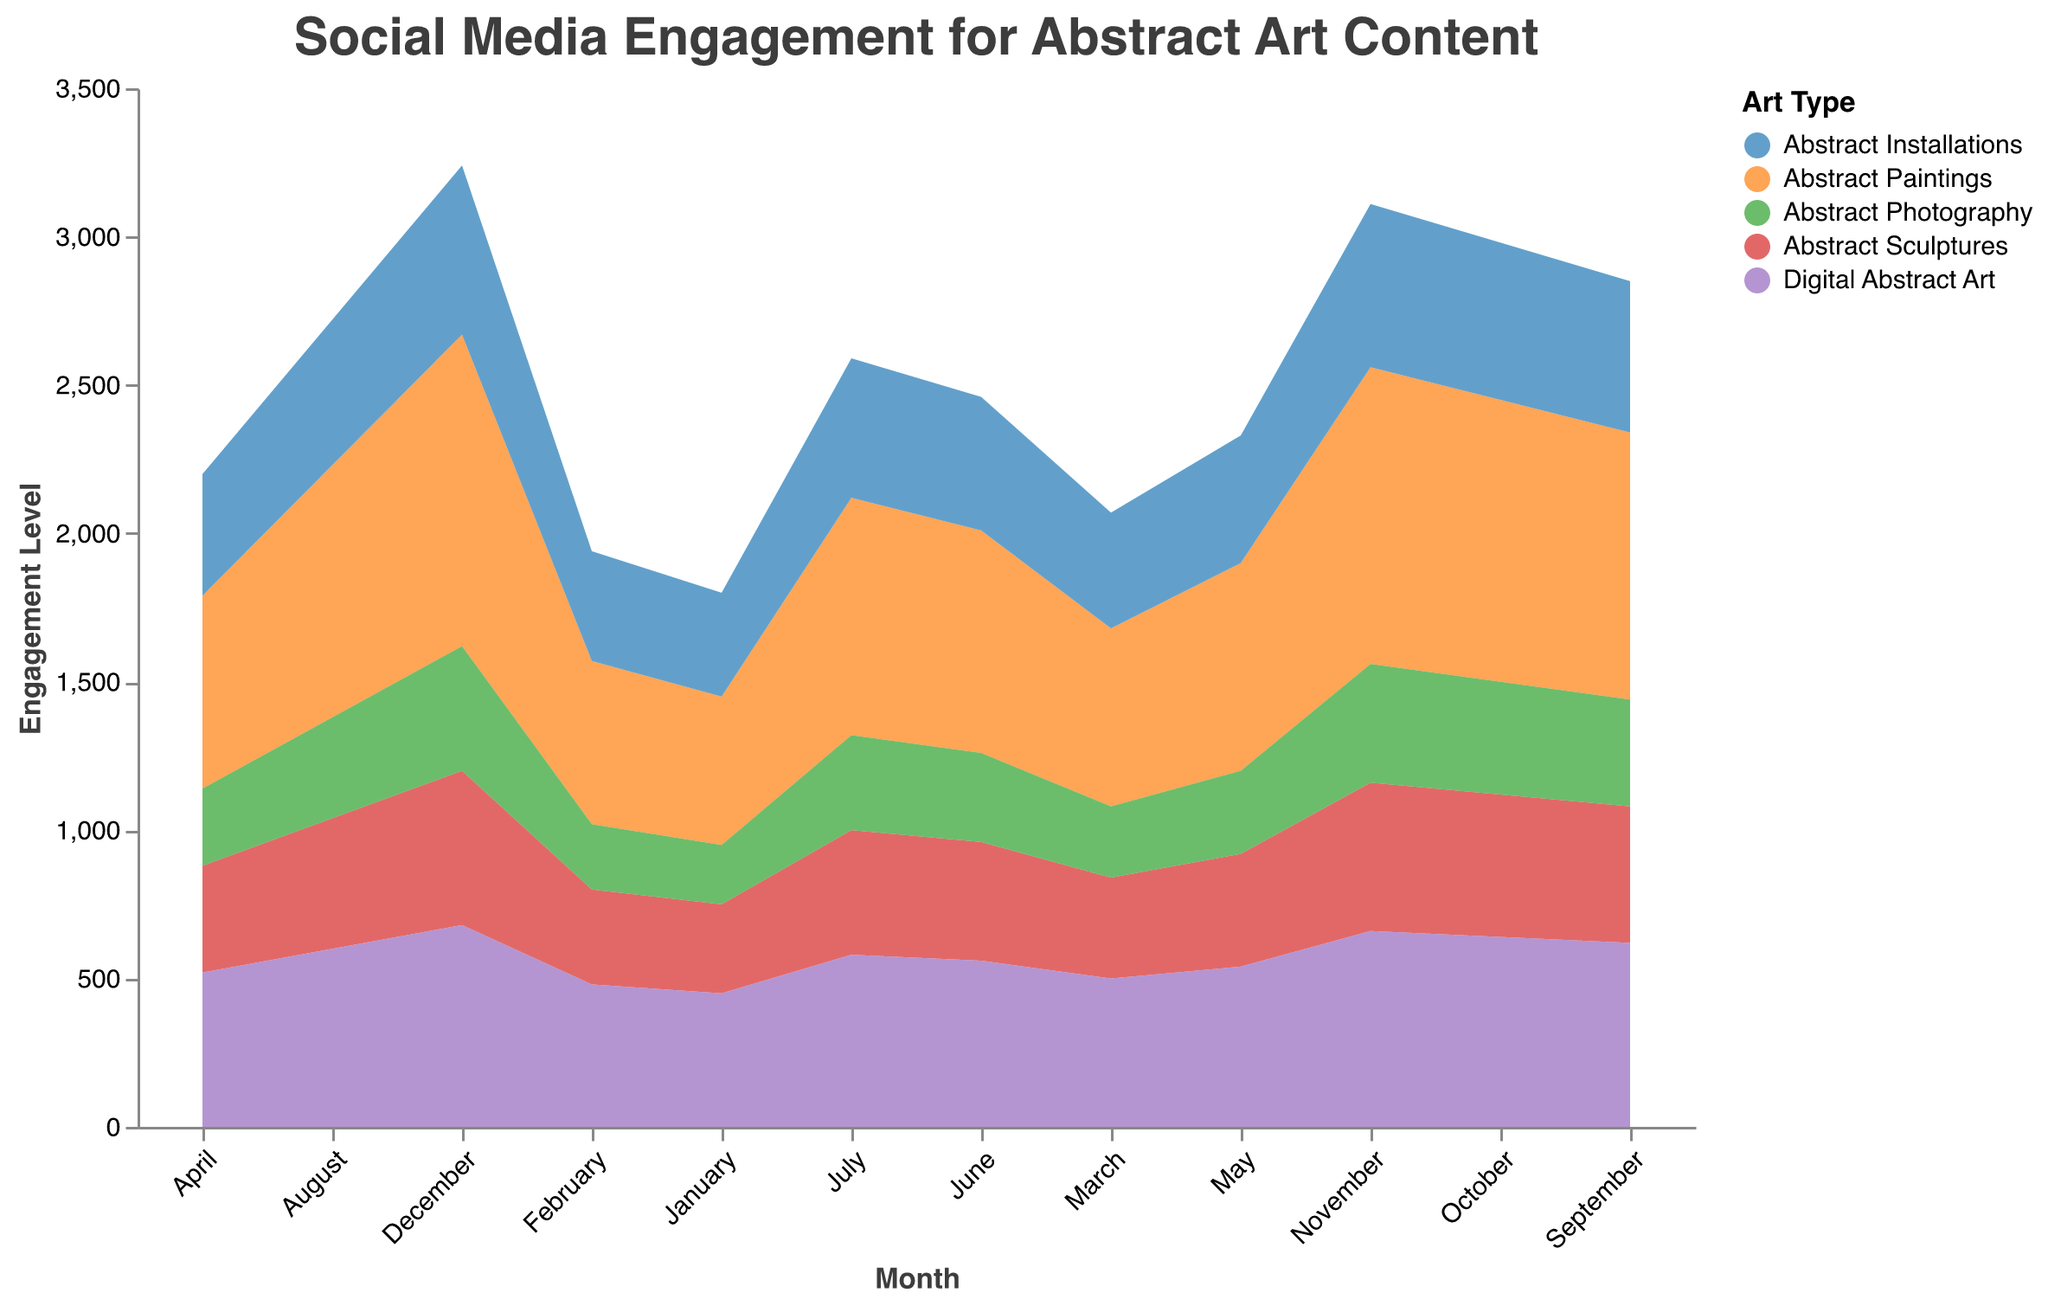What is the title of the chart? The title is positioned at the top of the chart and is typically written in a larger font size to make it stand out. The provided code shows that the title text is "Social Media Engagement for Abstract Art Content".
Answer: Social Media Engagement for Abstract Art Content Which type of abstract art content has the highest engagement level in December? To determine which type of abstract art content has the highest engagement in December, we look at the data points for December. According to the data, "Abstract Paintings" has an engagement level of 1050, which is the highest among the art types listed.
Answer: Abstract Paintings What is the trend for Digital Abstract Art engagement from January to December? Observing the data points for "Digital Abstract Art" from January (450) to December (680), it's clear that there is a consistent increase in engagement each month. This can be seen in the area chart as a continuously rising line.
Answer: Increasing trend How does the engagement for Abstract Installations compare to Abstract Sculptures in June? For June, we compare the engagement levels of "Abstract Installations" (450) and "Abstract Sculptures" (400). Engaging the two values, Abstract Installations has a higher engagement level than Abstract Sculptures.
Answer: Abstract Installations is higher What is the average engagement level of Abstract Photography across the whole year? To find the average, we add the engagement levels of Abstract Photography for each month and then divide by 12 (number of months). The sum is (200 + 220 + 240 + 260 + 280 + 300 + 320 + 340 + 360 + 380 + 400 + 420 = 3720). Dividing by 12 gives 3720 / 12 = 310.
Answer: 310 During which month does Abstract Paintings reach an engagement level of 800? Referring to the data, the engagement level for Abstract Paintings reaches 800 in the month of July. This can also be visually confirmed in the chart where the area corresponding to "Abstract Paintings" intersects the 800-level mark in July.
Answer: July What is the combined engagement level of Abstract Paintings and Digital Abstract Art in November? The engagement levels of Abstract Paintings and Digital Abstract Art in November are 1000 and 660 respectively. Adding these together gives 1000 + 660 = 1660.
Answer: 1660 Which type of abstract art content shows the least change in engagement from January to December? To find the least change, we need to examine the change in engagement levels from January to December for each type. "Abstract Sculptures" changes from 300 in January to 520 in December, a change of 220. Other types show larger changes, so "Abstract Sculptures" shows the least change.
Answer: Abstract Sculptures 